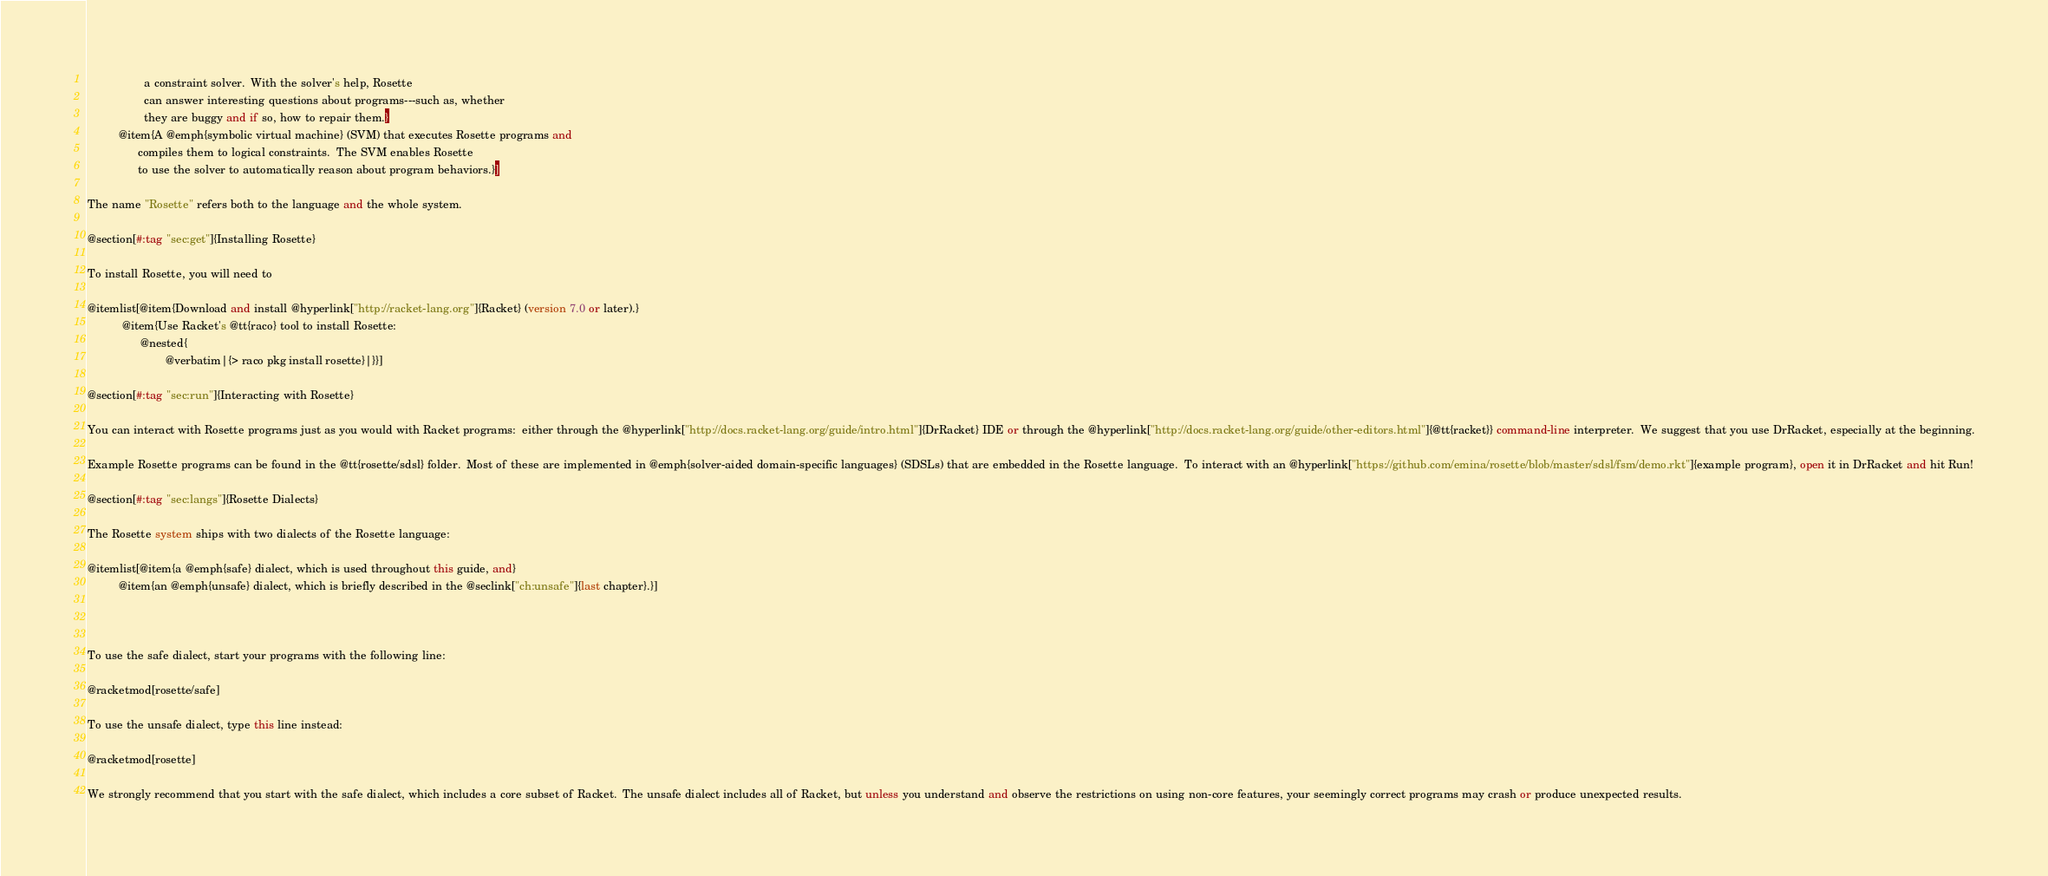<code> <loc_0><loc_0><loc_500><loc_500><_Racket_>                  a constraint solver.  With the solver's help, Rosette
                  can answer interesting questions about programs---such as, whether 
                  they are buggy and if so, how to repair them.}
          @item{A @emph{symbolic virtual machine} (SVM) that executes Rosette programs and 
                compiles them to logical constraints.  The SVM enables Rosette 
                to use the solver to automatically reason about program behaviors.}]

The name "Rosette" refers both to the language and the whole system.

@section[#:tag "sec:get"]{Installing Rosette}

To install Rosette, you will need to

@itemlist[@item{Download and install @hyperlink["http://racket-lang.org"]{Racket} (version 7.0 or later).}
           @item{Use Racket's @tt{raco} tool to install Rosette:
                 @nested{
                         @verbatim|{> raco pkg install rosette}|}}]

@section[#:tag "sec:run"]{Interacting with Rosette}

You can interact with Rosette programs just as you would with Racket programs:  either through the @hyperlink["http://docs.racket-lang.org/guide/intro.html"]{DrRacket} IDE or through the @hyperlink["http://docs.racket-lang.org/guide/other-editors.html"]{@tt{racket}} command-line interpreter.  We suggest that you use DrRacket, especially at the beginning.

Example Rosette programs can be found in the @tt{rosette/sdsl} folder.  Most of these are implemented in @emph{solver-aided domain-specific languages} (SDSLs) that are embedded in the Rosette language.  To interact with an @hyperlink["https://github.com/emina/rosette/blob/master/sdsl/fsm/demo.rkt"]{example program}, open it in DrRacket and hit Run!

@section[#:tag "sec:langs"]{Rosette Dialects}

The Rosette system ships with two dialects of the Rosette language: 

@itemlist[@item{a @emph{safe} dialect, which is used throughout this guide, and}
          @item{an @emph{unsafe} dialect, which is briefly described in the @seclink["ch:unsafe"]{last chapter}.}]



To use the safe dialect, start your programs with the following line:

@racketmod[rosette/safe]

To use the unsafe dialect, type this line instead:

@racketmod[rosette]

We strongly recommend that you start with the safe dialect, which includes a core subset of Racket.  The unsafe dialect includes all of Racket, but unless you understand and observe the restrictions on using non-core features, your seemingly correct programs may crash or produce unexpected results.

</code> 